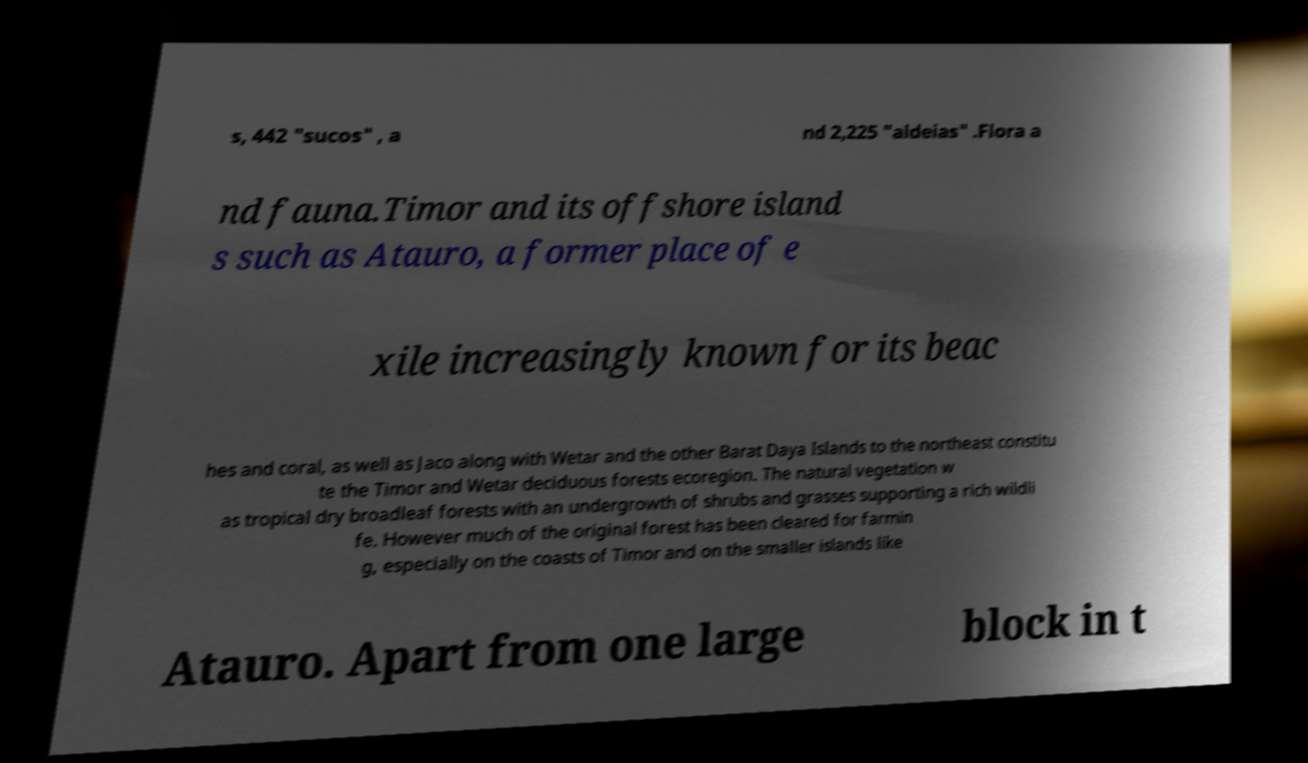What messages or text are displayed in this image? I need them in a readable, typed format. s, 442 "sucos" , a nd 2,225 "aldeias" .Flora a nd fauna.Timor and its offshore island s such as Atauro, a former place of e xile increasingly known for its beac hes and coral, as well as Jaco along with Wetar and the other Barat Daya Islands to the northeast constitu te the Timor and Wetar deciduous forests ecoregion. The natural vegetation w as tropical dry broadleaf forests with an undergrowth of shrubs and grasses supporting a rich wildli fe. However much of the original forest has been cleared for farmin g, especially on the coasts of Timor and on the smaller islands like Atauro. Apart from one large block in t 